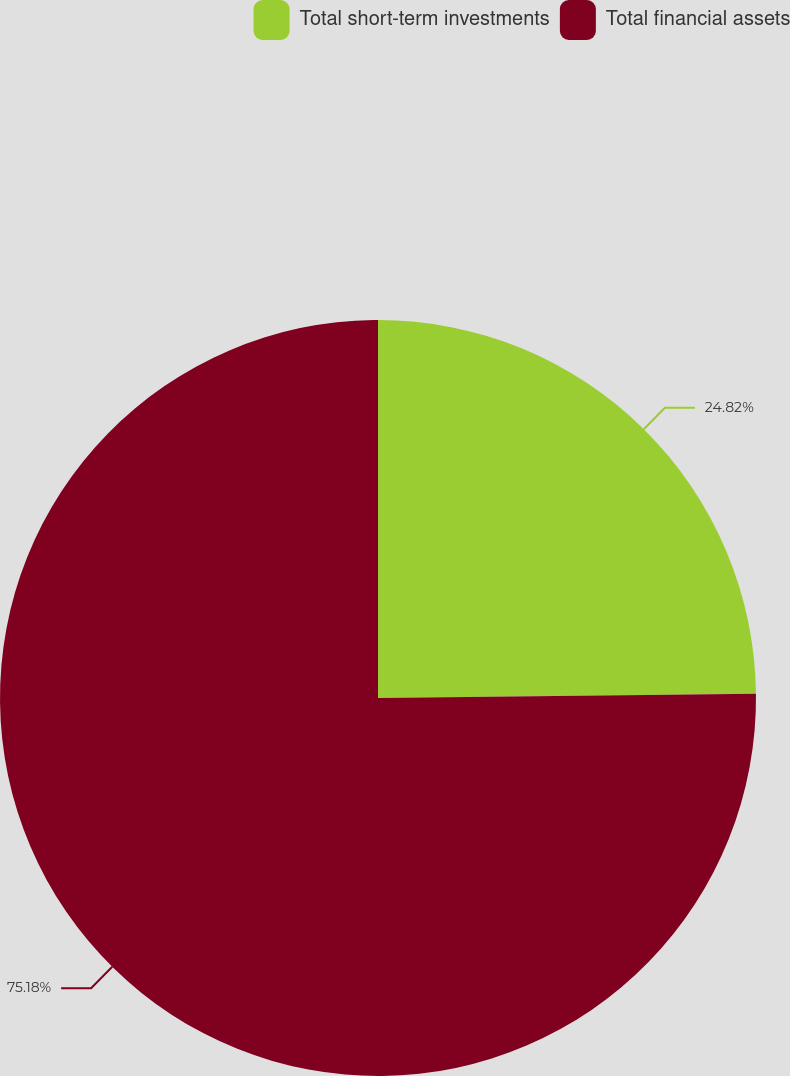Convert chart. <chart><loc_0><loc_0><loc_500><loc_500><pie_chart><fcel>Total short-term investments<fcel>Total financial assets<nl><fcel>24.82%<fcel>75.18%<nl></chart> 